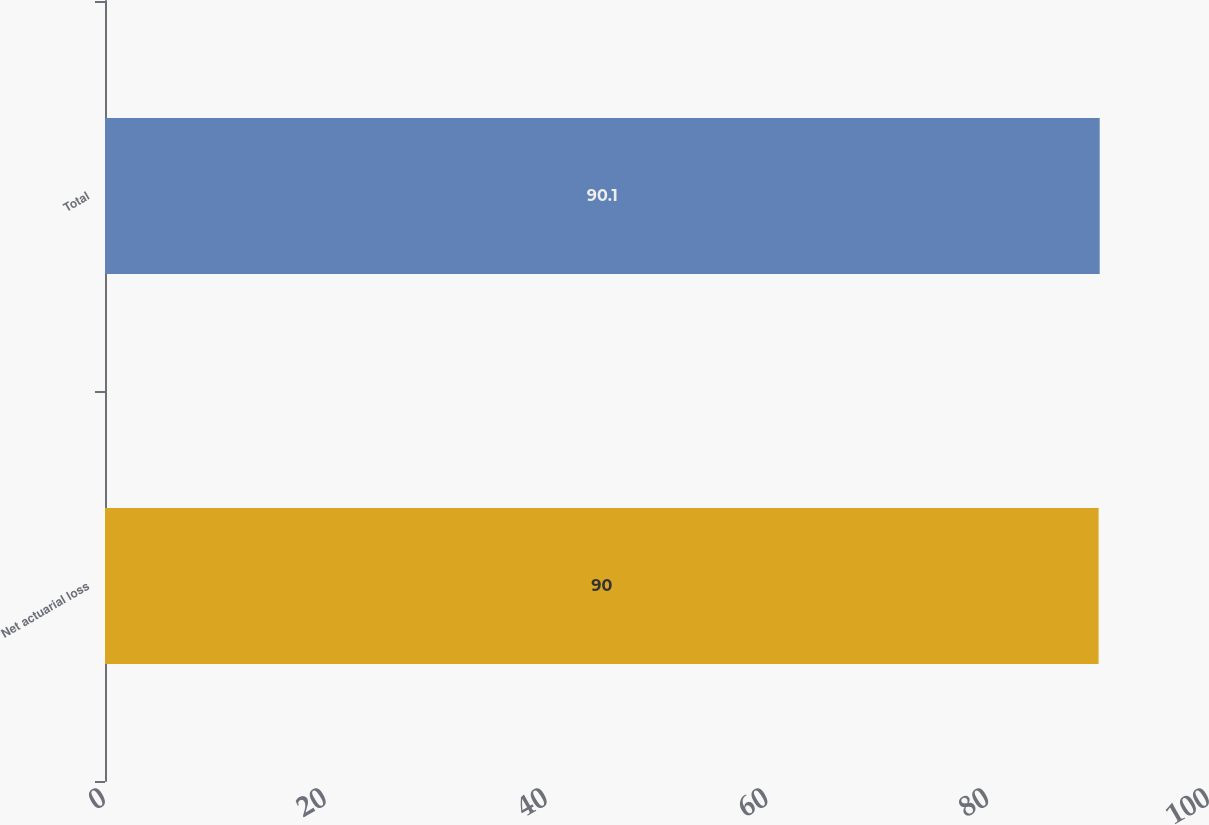Convert chart to OTSL. <chart><loc_0><loc_0><loc_500><loc_500><bar_chart><fcel>Net actuarial loss<fcel>Total<nl><fcel>90<fcel>90.1<nl></chart> 